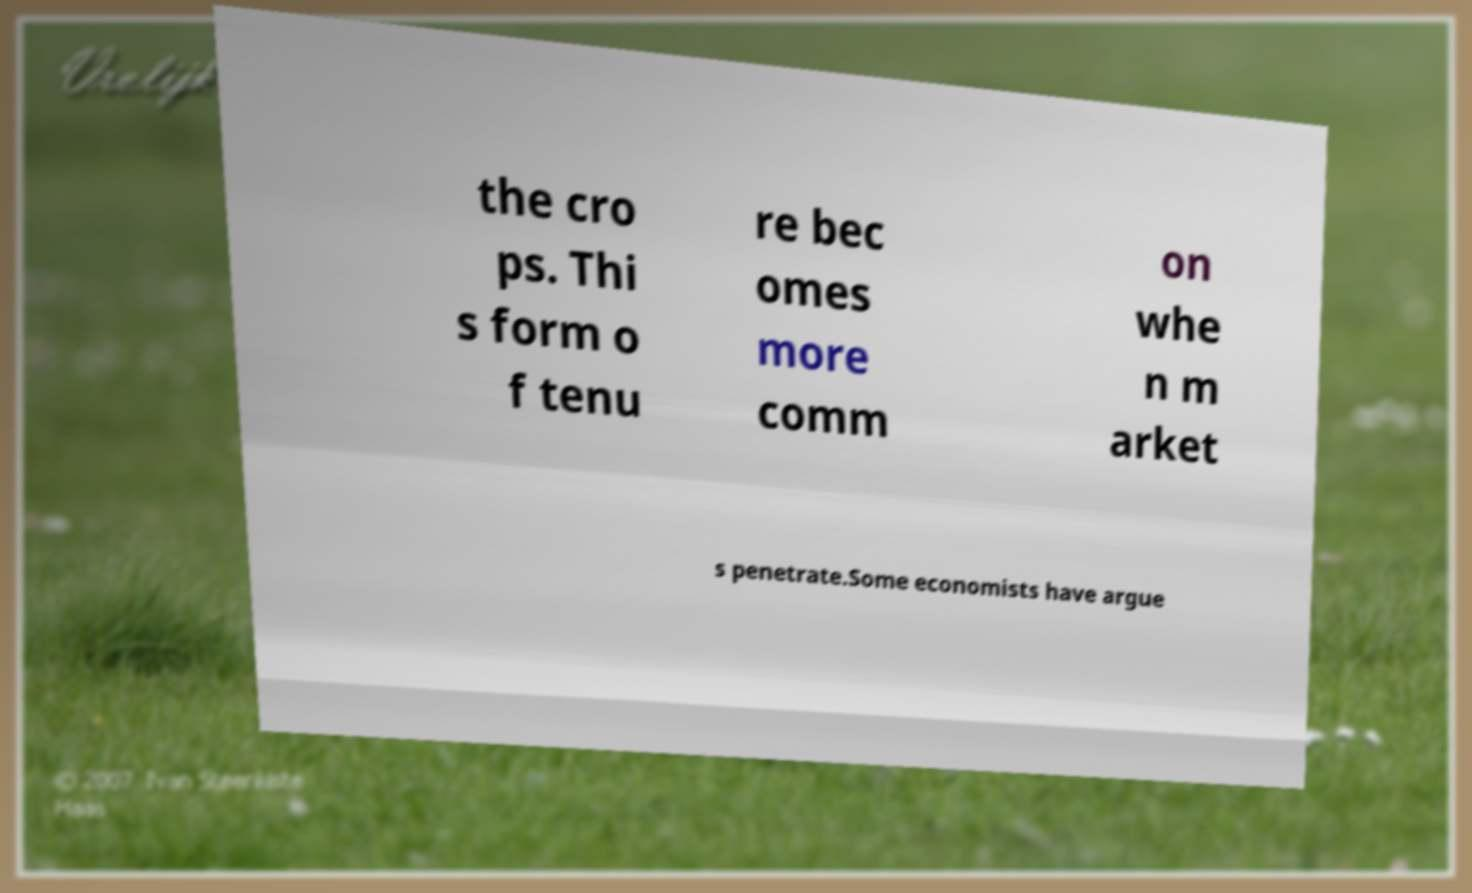Can you read and provide the text displayed in the image?This photo seems to have some interesting text. Can you extract and type it out for me? the cro ps. Thi s form o f tenu re bec omes more comm on whe n m arket s penetrate.Some economists have argue 